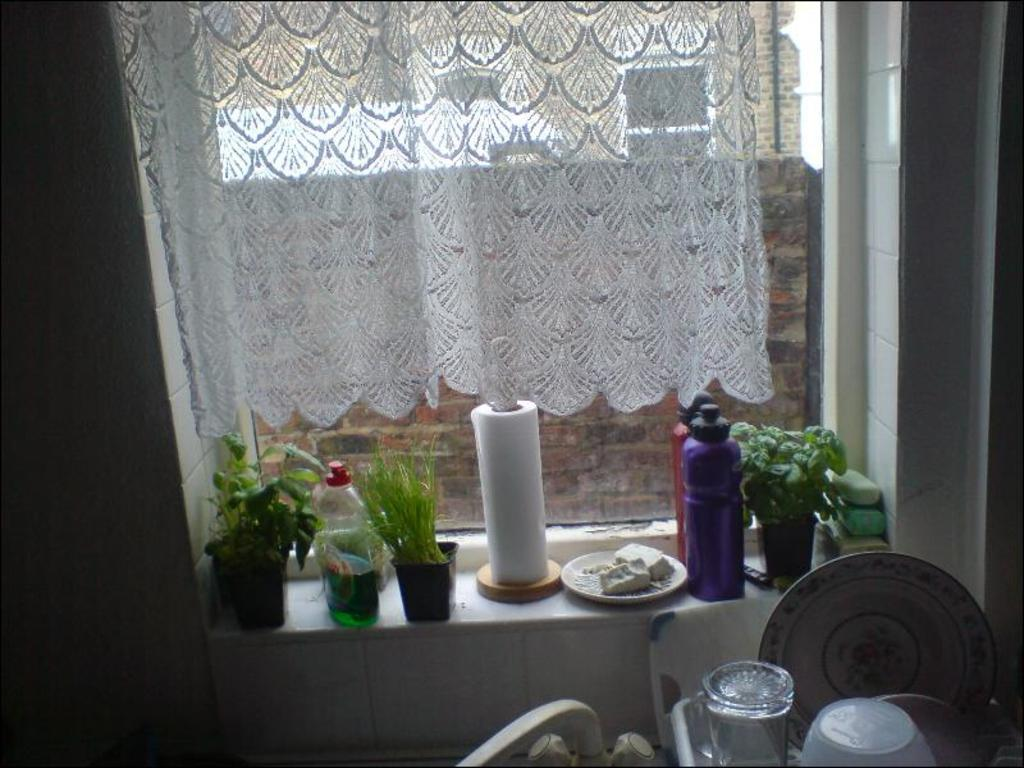What can be found in the room that provides a view of the outside? There is a window in the room. What is covering the window? The window has a curtain. What is placed near the window? There are flower pots and bottles near the window. What is located near the window for wiping or blowing one's nose? There is a tissue roll near the window. What piece of furniture is in the room for placing items? There is a table in the room. What is on the table that is transparent and used for serving food? The table has glass plates. What is on the table that is used for holding food? The table has bowls. What type of animal is causing the commotion outside the window in the image? There is no animal or commotion visible in the image; it only shows the window, curtain, flower pots, bottles, tissue roll, table, glass plates, and bowls. 